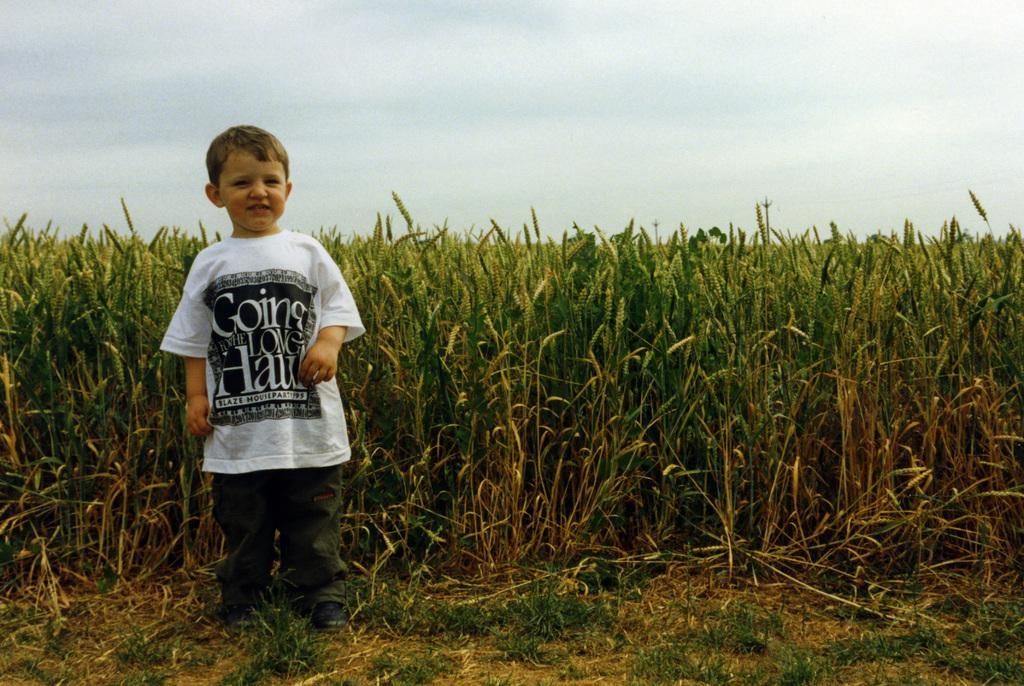Please provide a concise description of this image. In this picture we can see a boy smiling and standing on the ground, plants and in the background we can see the sky. 